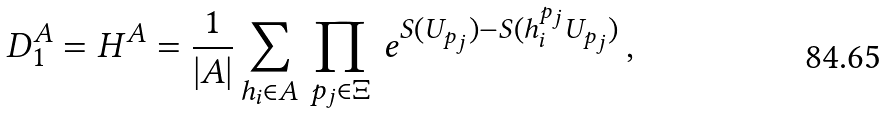Convert formula to latex. <formula><loc_0><loc_0><loc_500><loc_500>D ^ { A } _ { 1 } = H ^ { A } = \frac { 1 } { | A | } \sum _ { h _ { i } \in A } \, \prod _ { p _ { j } \in \Xi } \, e ^ { S ( U _ { p _ { j } } ) - S ( h _ { i } ^ { p _ { j } } U _ { p _ { j } } ) } \, ,</formula> 